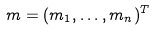Convert formula to latex. <formula><loc_0><loc_0><loc_500><loc_500>m = ( m _ { 1 } , \dots , m _ { n } ) ^ { T }</formula> 